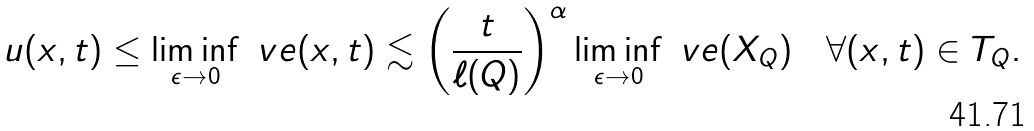Convert formula to latex. <formula><loc_0><loc_0><loc_500><loc_500>u ( x , t ) \leq \liminf _ { \epsilon \to 0 } \ v e ( x , t ) \lesssim \left ( \frac { t } { \ell ( Q ) } \right ) ^ { \alpha } \liminf _ { \epsilon \to 0 } \ v e ( X _ { Q } ) \quad \forall ( x , t ) \in T _ { Q } .</formula> 